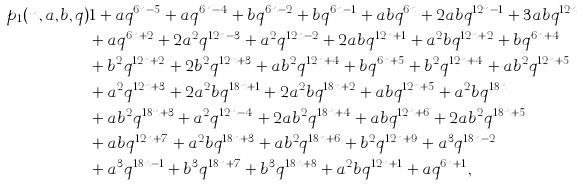<formula> <loc_0><loc_0><loc_500><loc_500>p _ { 1 } ( n , a , b , q ) & 1 + a q ^ { 6 n - 5 } + a q ^ { 6 n - 4 } + b q ^ { 6 n - 2 } + b q ^ { 6 n - 1 } + a b q ^ { 6 n } + 2 a b q ^ { 1 2 n - 1 } + 3 a b q ^ { 1 2 n } \\ & + a q ^ { 6 n + 2 } + 2 a ^ { 2 } q ^ { 1 2 n - 3 } + a ^ { 2 } q ^ { 1 2 n - 2 } + 2 a b q ^ { 1 2 n + 1 } + a ^ { 2 } b q ^ { 1 2 n + 2 } + b q ^ { 6 n + 4 } \\ & + b ^ { 2 } q ^ { 1 2 n + 2 } + 2 b ^ { 2 } q ^ { 1 2 n + 3 } + a b ^ { 2 } q ^ { 1 2 n + 4 } + b q ^ { 6 n + 5 } + b ^ { 2 } q ^ { 1 2 n + 4 } + a b ^ { 2 } q ^ { 1 2 n + 5 } \\ & + a ^ { 2 } q ^ { 1 2 n + 3 } + 2 a ^ { 2 } b q ^ { 1 8 n + 1 } + 2 a ^ { 2 } b q ^ { 1 8 n + 2 } + a b q ^ { 1 2 n + 5 } + a ^ { 2 } b q ^ { 1 8 n } \\ & + a b ^ { 2 } q ^ { 1 8 n + 3 } + a ^ { 2 } q ^ { 1 2 n - 4 } + 2 a b ^ { 2 } q ^ { 1 8 n + 4 } + a b q ^ { 1 2 n + 6 } + 2 a b ^ { 2 } q ^ { 1 8 n + 5 } \\ & + a b q ^ { 1 2 n + 7 } + a ^ { 2 } b q ^ { 1 8 n + 3 } + a b ^ { 2 } q ^ { 1 8 n + 6 } + b ^ { 2 } q ^ { 1 2 n + 9 } + a ^ { 3 } q ^ { 1 8 n - 2 } \\ & + a ^ { 3 } q ^ { 1 8 n - 1 } + b ^ { 3 } q ^ { 1 8 n + 7 } + b ^ { 3 } q ^ { 1 8 n + 8 } + a ^ { 2 } b q ^ { 1 2 n + 1 } + a q ^ { 6 n + 1 } ,</formula> 